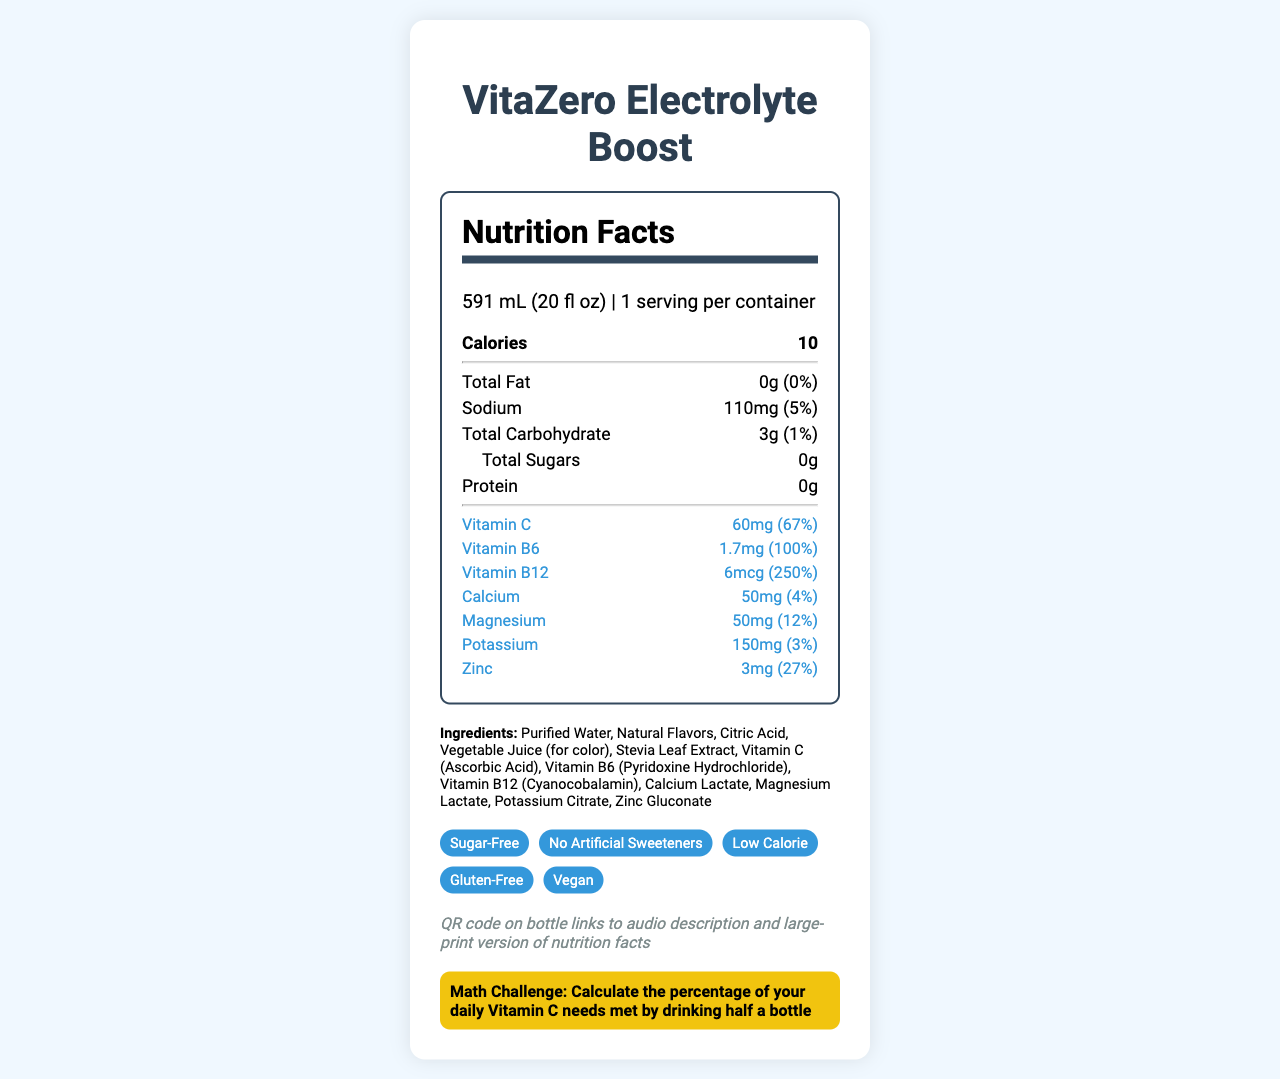What is the serving size of VitaZero Electrolyte Boost? The serving size information is clearly stated under the Nutrition Facts section.
Answer: 591 mL (20 fl oz) How many calories does one serving of VitaZero Electrolyte Boost contain? The number of calories is specified in bold in the Nutrition Facts section.
Answer: 10 What percentage of your daily Vitamin C needs is met by one serving of this product? The daily value percentage for Vitamin C is listed as 67% in the Nutrition Facts section.
Answer: 67% Which vitamins are added to the VitaZero Electrolyte Boost? The added vitamins are listed in the Nutrition Facts section under their respective amounts and daily values.
Answer: Vitamin C, Vitamin B6, Vitamin B12 How much protein does one serving of VitaZero Electrolyte Boost provide? The amount of protein is clearly stated in the Nutrition Facts section as 0g.
Answer: 0g What is the main sweetener used in VitaZero Electrolyte Boost? A. Aspartame B. Sucralose C. Stevia Leaf Extract D. Sugar The ingredients list shows Stevia Leaf Extract is used as the sweetener.
Answer: C. Stevia Leaf Extract Which of these statements about the product's features is true? A. It contains artificial sweeteners B. It is gluten-free C. It has high calories D. It contains dairy The special features section includes "Gluten-Free" among other descriptors.
Answer: B. It is gluten-free Is VitaZero Electrolyte Boost vegan-friendly? The special features section states that the product is "Vegan."
Answer: Yes Does VitaZero Electrolyte Boost contain any major allergens? The allergen information clearly states "Contains no major allergens."
Answer: No What percentage of your daily magnesium needs is met by one serving of this product? The Nutrition Facts section lists the daily value percentage for magnesium as 12%.
Answer: 12% Summarize the main idea of the document. The document presents detailed nutritional information, ingredient list, special product features, and assistive technology details to describe the health benefits and accessibility features of the product.
Answer: VitaZero Electrolyte Boost is a low-calorie, sugar-free vitamin water that offers electrolytes and added vitamins such as Vitamin C, B6, and B12. It is also gluten-free and vegan, with no major allergens, and includes assistive tech information for accessibility. Calculate the percentage of your daily Vitamin C needs met by drinking half a bottle. One serving meets 67% of the daily Vitamin C needs. Drinking half a bottle, which is half a serving, would meet 33.5% of the daily Vitamin C needs. (67% / 2 = 33.5%)
Answer: 33.5% What is the sodium content in one serving of VitaZero Electrolyte Boost? The amount of sodium per serving is listed in the Nutrition Facts section as 110mg.
Answer: 110mg List three electrolytes present in VitaZero Electrolyte Boost. The Nutrition Facts section lists Sodium (110mg), Magnesium (50mg), and Potassium (150mg) among the ingredients.
Answer: Sodium, Magnesium, Potassium What is the daily value percentage for Zinc provided by this product? The daily value percentage for Zinc is clearly stated in the Nutrition Facts section as 27%.
Answer: 27% Does the document specify the manufacturing location of VitaZero Electrolyte Boost? The document does not provide any details about the manufacturing location.
Answer: Not enough information 